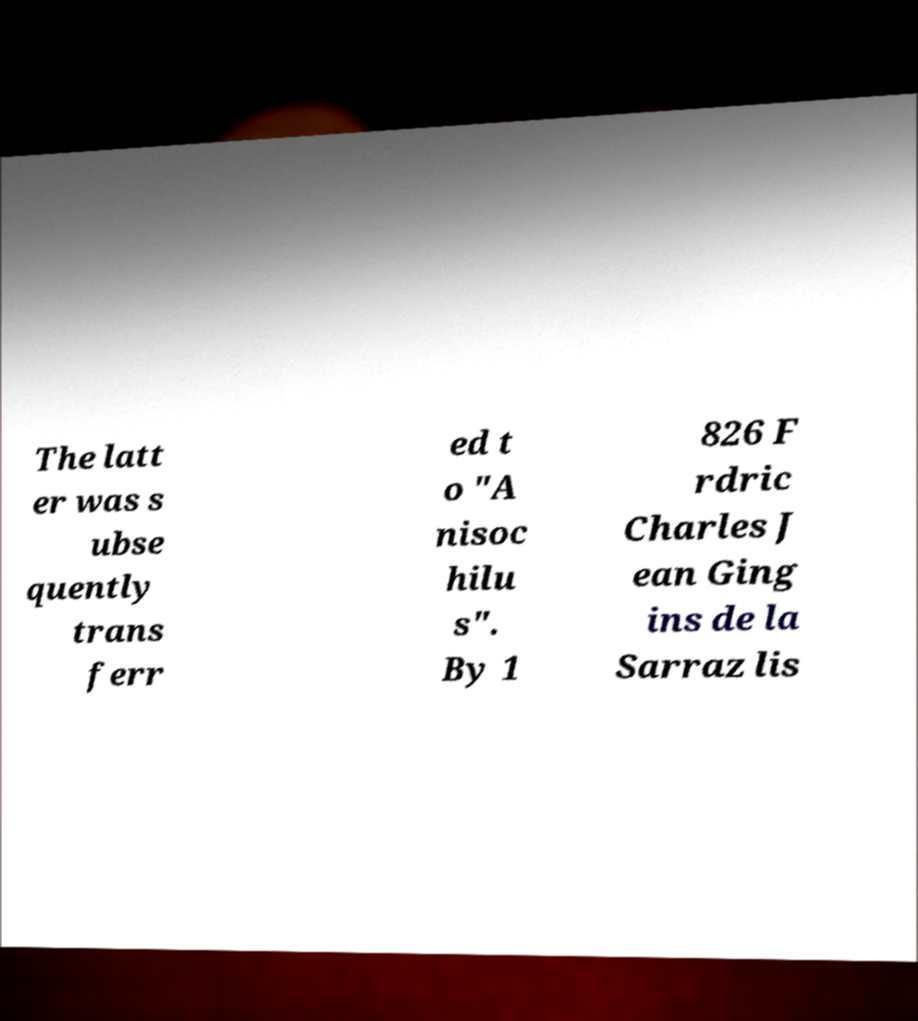Could you assist in decoding the text presented in this image and type it out clearly? The latt er was s ubse quently trans ferr ed t o "A nisoc hilu s". By 1 826 F rdric Charles J ean Ging ins de la Sarraz lis 